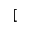<formula> <loc_0><loc_0><loc_500><loc_500>[</formula> 